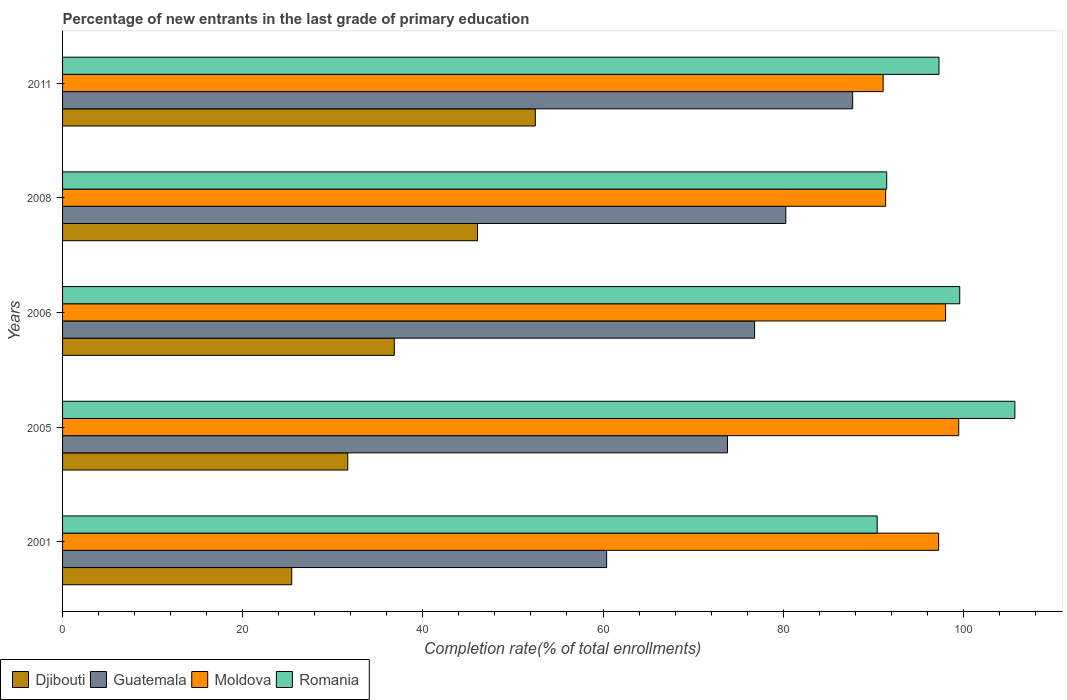How many different coloured bars are there?
Offer a terse response. 4. Are the number of bars on each tick of the Y-axis equal?
Your answer should be very brief. Yes. How many bars are there on the 3rd tick from the top?
Give a very brief answer. 4. How many bars are there on the 2nd tick from the bottom?
Ensure brevity in your answer.  4. What is the percentage of new entrants in Romania in 2006?
Offer a very short reply. 99.6. Across all years, what is the maximum percentage of new entrants in Djibouti?
Your answer should be very brief. 52.48. Across all years, what is the minimum percentage of new entrants in Moldova?
Offer a terse response. 91.1. In which year was the percentage of new entrants in Moldova maximum?
Offer a very short reply. 2005. In which year was the percentage of new entrants in Romania minimum?
Your answer should be very brief. 2001. What is the total percentage of new entrants in Guatemala in the graph?
Provide a short and direct response. 379.07. What is the difference between the percentage of new entrants in Romania in 2005 and that in 2006?
Your answer should be very brief. 6.12. What is the difference between the percentage of new entrants in Moldova in 2006 and the percentage of new entrants in Romania in 2008?
Your response must be concise. 6.54. What is the average percentage of new entrants in Guatemala per year?
Ensure brevity in your answer.  75.81. In the year 2005, what is the difference between the percentage of new entrants in Romania and percentage of new entrants in Moldova?
Provide a short and direct response. 6.23. In how many years, is the percentage of new entrants in Romania greater than 80 %?
Your answer should be compact. 5. What is the ratio of the percentage of new entrants in Guatemala in 2001 to that in 2006?
Provide a short and direct response. 0.79. What is the difference between the highest and the second highest percentage of new entrants in Romania?
Offer a terse response. 6.12. What is the difference between the highest and the lowest percentage of new entrants in Djibouti?
Your response must be concise. 27.04. Is the sum of the percentage of new entrants in Romania in 2006 and 2011 greater than the maximum percentage of new entrants in Guatemala across all years?
Your answer should be very brief. Yes. What does the 1st bar from the top in 2006 represents?
Keep it short and to the point. Romania. What does the 4th bar from the bottom in 2008 represents?
Ensure brevity in your answer.  Romania. How many years are there in the graph?
Offer a very short reply. 5. What is the difference between two consecutive major ticks on the X-axis?
Your answer should be compact. 20. Does the graph contain any zero values?
Your response must be concise. No. Where does the legend appear in the graph?
Provide a succinct answer. Bottom left. How are the legend labels stacked?
Your response must be concise. Horizontal. What is the title of the graph?
Make the answer very short. Percentage of new entrants in the last grade of primary education. Does "Qatar" appear as one of the legend labels in the graph?
Your response must be concise. No. What is the label or title of the X-axis?
Provide a succinct answer. Completion rate(% of total enrollments). What is the Completion rate(% of total enrollments) of Djibouti in 2001?
Provide a succinct answer. 25.44. What is the Completion rate(% of total enrollments) in Guatemala in 2001?
Your answer should be very brief. 60.4. What is the Completion rate(% of total enrollments) in Moldova in 2001?
Your answer should be compact. 97.26. What is the Completion rate(% of total enrollments) in Romania in 2001?
Provide a succinct answer. 90.44. What is the Completion rate(% of total enrollments) of Djibouti in 2005?
Provide a succinct answer. 31.66. What is the Completion rate(% of total enrollments) of Guatemala in 2005?
Your response must be concise. 73.82. What is the Completion rate(% of total enrollments) in Moldova in 2005?
Provide a short and direct response. 99.49. What is the Completion rate(% of total enrollments) of Romania in 2005?
Your answer should be compact. 105.72. What is the Completion rate(% of total enrollments) of Djibouti in 2006?
Offer a very short reply. 36.83. What is the Completion rate(% of total enrollments) in Guatemala in 2006?
Offer a terse response. 76.83. What is the Completion rate(% of total enrollments) in Moldova in 2006?
Your answer should be compact. 98.03. What is the Completion rate(% of total enrollments) in Romania in 2006?
Ensure brevity in your answer.  99.6. What is the Completion rate(% of total enrollments) of Djibouti in 2008?
Your answer should be compact. 46.07. What is the Completion rate(% of total enrollments) of Guatemala in 2008?
Provide a succinct answer. 80.29. What is the Completion rate(% of total enrollments) in Moldova in 2008?
Ensure brevity in your answer.  91.38. What is the Completion rate(% of total enrollments) in Romania in 2008?
Provide a short and direct response. 91.5. What is the Completion rate(% of total enrollments) in Djibouti in 2011?
Give a very brief answer. 52.48. What is the Completion rate(% of total enrollments) in Guatemala in 2011?
Offer a terse response. 87.72. What is the Completion rate(% of total enrollments) of Moldova in 2011?
Offer a very short reply. 91.1. What is the Completion rate(% of total enrollments) in Romania in 2011?
Your answer should be very brief. 97.3. Across all years, what is the maximum Completion rate(% of total enrollments) of Djibouti?
Offer a very short reply. 52.48. Across all years, what is the maximum Completion rate(% of total enrollments) in Guatemala?
Provide a short and direct response. 87.72. Across all years, what is the maximum Completion rate(% of total enrollments) in Moldova?
Give a very brief answer. 99.49. Across all years, what is the maximum Completion rate(% of total enrollments) of Romania?
Offer a very short reply. 105.72. Across all years, what is the minimum Completion rate(% of total enrollments) in Djibouti?
Your answer should be compact. 25.44. Across all years, what is the minimum Completion rate(% of total enrollments) of Guatemala?
Keep it short and to the point. 60.4. Across all years, what is the minimum Completion rate(% of total enrollments) in Moldova?
Provide a short and direct response. 91.1. Across all years, what is the minimum Completion rate(% of total enrollments) in Romania?
Provide a succinct answer. 90.44. What is the total Completion rate(% of total enrollments) in Djibouti in the graph?
Make the answer very short. 192.49. What is the total Completion rate(% of total enrollments) of Guatemala in the graph?
Give a very brief answer. 379.07. What is the total Completion rate(% of total enrollments) of Moldova in the graph?
Give a very brief answer. 477.26. What is the total Completion rate(% of total enrollments) of Romania in the graph?
Ensure brevity in your answer.  484.56. What is the difference between the Completion rate(% of total enrollments) in Djibouti in 2001 and that in 2005?
Offer a very short reply. -6.22. What is the difference between the Completion rate(% of total enrollments) in Guatemala in 2001 and that in 2005?
Your answer should be very brief. -13.42. What is the difference between the Completion rate(% of total enrollments) in Moldova in 2001 and that in 2005?
Make the answer very short. -2.23. What is the difference between the Completion rate(% of total enrollments) of Romania in 2001 and that in 2005?
Your answer should be very brief. -15.28. What is the difference between the Completion rate(% of total enrollments) of Djibouti in 2001 and that in 2006?
Ensure brevity in your answer.  -11.39. What is the difference between the Completion rate(% of total enrollments) in Guatemala in 2001 and that in 2006?
Your response must be concise. -16.43. What is the difference between the Completion rate(% of total enrollments) of Moldova in 2001 and that in 2006?
Make the answer very short. -0.77. What is the difference between the Completion rate(% of total enrollments) in Romania in 2001 and that in 2006?
Offer a very short reply. -9.16. What is the difference between the Completion rate(% of total enrollments) in Djibouti in 2001 and that in 2008?
Keep it short and to the point. -20.63. What is the difference between the Completion rate(% of total enrollments) in Guatemala in 2001 and that in 2008?
Offer a very short reply. -19.89. What is the difference between the Completion rate(% of total enrollments) of Moldova in 2001 and that in 2008?
Your response must be concise. 5.88. What is the difference between the Completion rate(% of total enrollments) in Romania in 2001 and that in 2008?
Your response must be concise. -1.05. What is the difference between the Completion rate(% of total enrollments) of Djibouti in 2001 and that in 2011?
Offer a terse response. -27.04. What is the difference between the Completion rate(% of total enrollments) in Guatemala in 2001 and that in 2011?
Provide a short and direct response. -27.32. What is the difference between the Completion rate(% of total enrollments) of Moldova in 2001 and that in 2011?
Your response must be concise. 6.16. What is the difference between the Completion rate(% of total enrollments) of Romania in 2001 and that in 2011?
Offer a very short reply. -6.86. What is the difference between the Completion rate(% of total enrollments) in Djibouti in 2005 and that in 2006?
Ensure brevity in your answer.  -5.16. What is the difference between the Completion rate(% of total enrollments) of Guatemala in 2005 and that in 2006?
Keep it short and to the point. -3.01. What is the difference between the Completion rate(% of total enrollments) in Moldova in 2005 and that in 2006?
Your response must be concise. 1.46. What is the difference between the Completion rate(% of total enrollments) in Romania in 2005 and that in 2006?
Keep it short and to the point. 6.12. What is the difference between the Completion rate(% of total enrollments) of Djibouti in 2005 and that in 2008?
Provide a succinct answer. -14.41. What is the difference between the Completion rate(% of total enrollments) of Guatemala in 2005 and that in 2008?
Offer a terse response. -6.47. What is the difference between the Completion rate(% of total enrollments) in Moldova in 2005 and that in 2008?
Provide a short and direct response. 8.11. What is the difference between the Completion rate(% of total enrollments) of Romania in 2005 and that in 2008?
Provide a succinct answer. 14.23. What is the difference between the Completion rate(% of total enrollments) in Djibouti in 2005 and that in 2011?
Provide a succinct answer. -20.82. What is the difference between the Completion rate(% of total enrollments) of Guatemala in 2005 and that in 2011?
Give a very brief answer. -13.9. What is the difference between the Completion rate(% of total enrollments) in Moldova in 2005 and that in 2011?
Offer a terse response. 8.39. What is the difference between the Completion rate(% of total enrollments) of Romania in 2005 and that in 2011?
Keep it short and to the point. 8.43. What is the difference between the Completion rate(% of total enrollments) in Djibouti in 2006 and that in 2008?
Provide a short and direct response. -9.24. What is the difference between the Completion rate(% of total enrollments) in Guatemala in 2006 and that in 2008?
Your answer should be compact. -3.46. What is the difference between the Completion rate(% of total enrollments) in Moldova in 2006 and that in 2008?
Provide a short and direct response. 6.65. What is the difference between the Completion rate(% of total enrollments) of Romania in 2006 and that in 2008?
Your answer should be compact. 8.11. What is the difference between the Completion rate(% of total enrollments) in Djibouti in 2006 and that in 2011?
Offer a very short reply. -15.66. What is the difference between the Completion rate(% of total enrollments) in Guatemala in 2006 and that in 2011?
Make the answer very short. -10.89. What is the difference between the Completion rate(% of total enrollments) in Moldova in 2006 and that in 2011?
Offer a very short reply. 6.93. What is the difference between the Completion rate(% of total enrollments) of Romania in 2006 and that in 2011?
Your answer should be very brief. 2.31. What is the difference between the Completion rate(% of total enrollments) of Djibouti in 2008 and that in 2011?
Your answer should be very brief. -6.41. What is the difference between the Completion rate(% of total enrollments) of Guatemala in 2008 and that in 2011?
Your response must be concise. -7.42. What is the difference between the Completion rate(% of total enrollments) in Moldova in 2008 and that in 2011?
Your response must be concise. 0.28. What is the difference between the Completion rate(% of total enrollments) of Romania in 2008 and that in 2011?
Make the answer very short. -5.8. What is the difference between the Completion rate(% of total enrollments) of Djibouti in 2001 and the Completion rate(% of total enrollments) of Guatemala in 2005?
Provide a succinct answer. -48.38. What is the difference between the Completion rate(% of total enrollments) in Djibouti in 2001 and the Completion rate(% of total enrollments) in Moldova in 2005?
Your answer should be compact. -74.05. What is the difference between the Completion rate(% of total enrollments) in Djibouti in 2001 and the Completion rate(% of total enrollments) in Romania in 2005?
Keep it short and to the point. -80.28. What is the difference between the Completion rate(% of total enrollments) in Guatemala in 2001 and the Completion rate(% of total enrollments) in Moldova in 2005?
Offer a very short reply. -39.09. What is the difference between the Completion rate(% of total enrollments) of Guatemala in 2001 and the Completion rate(% of total enrollments) of Romania in 2005?
Your response must be concise. -45.32. What is the difference between the Completion rate(% of total enrollments) of Moldova in 2001 and the Completion rate(% of total enrollments) of Romania in 2005?
Provide a succinct answer. -8.46. What is the difference between the Completion rate(% of total enrollments) of Djibouti in 2001 and the Completion rate(% of total enrollments) of Guatemala in 2006?
Provide a short and direct response. -51.39. What is the difference between the Completion rate(% of total enrollments) in Djibouti in 2001 and the Completion rate(% of total enrollments) in Moldova in 2006?
Make the answer very short. -72.59. What is the difference between the Completion rate(% of total enrollments) of Djibouti in 2001 and the Completion rate(% of total enrollments) of Romania in 2006?
Ensure brevity in your answer.  -74.16. What is the difference between the Completion rate(% of total enrollments) in Guatemala in 2001 and the Completion rate(% of total enrollments) in Moldova in 2006?
Your answer should be compact. -37.63. What is the difference between the Completion rate(% of total enrollments) of Guatemala in 2001 and the Completion rate(% of total enrollments) of Romania in 2006?
Keep it short and to the point. -39.2. What is the difference between the Completion rate(% of total enrollments) in Moldova in 2001 and the Completion rate(% of total enrollments) in Romania in 2006?
Your answer should be compact. -2.34. What is the difference between the Completion rate(% of total enrollments) in Djibouti in 2001 and the Completion rate(% of total enrollments) in Guatemala in 2008?
Ensure brevity in your answer.  -54.85. What is the difference between the Completion rate(% of total enrollments) in Djibouti in 2001 and the Completion rate(% of total enrollments) in Moldova in 2008?
Your response must be concise. -65.94. What is the difference between the Completion rate(% of total enrollments) in Djibouti in 2001 and the Completion rate(% of total enrollments) in Romania in 2008?
Offer a terse response. -66.05. What is the difference between the Completion rate(% of total enrollments) of Guatemala in 2001 and the Completion rate(% of total enrollments) of Moldova in 2008?
Provide a short and direct response. -30.97. What is the difference between the Completion rate(% of total enrollments) of Guatemala in 2001 and the Completion rate(% of total enrollments) of Romania in 2008?
Provide a succinct answer. -31.09. What is the difference between the Completion rate(% of total enrollments) of Moldova in 2001 and the Completion rate(% of total enrollments) of Romania in 2008?
Offer a terse response. 5.77. What is the difference between the Completion rate(% of total enrollments) of Djibouti in 2001 and the Completion rate(% of total enrollments) of Guatemala in 2011?
Your response must be concise. -62.28. What is the difference between the Completion rate(% of total enrollments) in Djibouti in 2001 and the Completion rate(% of total enrollments) in Moldova in 2011?
Provide a succinct answer. -65.66. What is the difference between the Completion rate(% of total enrollments) of Djibouti in 2001 and the Completion rate(% of total enrollments) of Romania in 2011?
Your answer should be very brief. -71.86. What is the difference between the Completion rate(% of total enrollments) of Guatemala in 2001 and the Completion rate(% of total enrollments) of Moldova in 2011?
Your answer should be compact. -30.7. What is the difference between the Completion rate(% of total enrollments) of Guatemala in 2001 and the Completion rate(% of total enrollments) of Romania in 2011?
Keep it short and to the point. -36.89. What is the difference between the Completion rate(% of total enrollments) in Moldova in 2001 and the Completion rate(% of total enrollments) in Romania in 2011?
Give a very brief answer. -0.03. What is the difference between the Completion rate(% of total enrollments) of Djibouti in 2005 and the Completion rate(% of total enrollments) of Guatemala in 2006?
Provide a short and direct response. -45.17. What is the difference between the Completion rate(% of total enrollments) of Djibouti in 2005 and the Completion rate(% of total enrollments) of Moldova in 2006?
Give a very brief answer. -66.37. What is the difference between the Completion rate(% of total enrollments) in Djibouti in 2005 and the Completion rate(% of total enrollments) in Romania in 2006?
Provide a short and direct response. -67.94. What is the difference between the Completion rate(% of total enrollments) of Guatemala in 2005 and the Completion rate(% of total enrollments) of Moldova in 2006?
Provide a succinct answer. -24.21. What is the difference between the Completion rate(% of total enrollments) in Guatemala in 2005 and the Completion rate(% of total enrollments) in Romania in 2006?
Offer a terse response. -25.78. What is the difference between the Completion rate(% of total enrollments) of Moldova in 2005 and the Completion rate(% of total enrollments) of Romania in 2006?
Your answer should be very brief. -0.11. What is the difference between the Completion rate(% of total enrollments) of Djibouti in 2005 and the Completion rate(% of total enrollments) of Guatemala in 2008?
Your answer should be compact. -48.63. What is the difference between the Completion rate(% of total enrollments) of Djibouti in 2005 and the Completion rate(% of total enrollments) of Moldova in 2008?
Your response must be concise. -59.71. What is the difference between the Completion rate(% of total enrollments) in Djibouti in 2005 and the Completion rate(% of total enrollments) in Romania in 2008?
Keep it short and to the point. -59.83. What is the difference between the Completion rate(% of total enrollments) in Guatemala in 2005 and the Completion rate(% of total enrollments) in Moldova in 2008?
Offer a very short reply. -17.56. What is the difference between the Completion rate(% of total enrollments) of Guatemala in 2005 and the Completion rate(% of total enrollments) of Romania in 2008?
Your answer should be compact. -17.67. What is the difference between the Completion rate(% of total enrollments) in Moldova in 2005 and the Completion rate(% of total enrollments) in Romania in 2008?
Offer a terse response. 7.99. What is the difference between the Completion rate(% of total enrollments) in Djibouti in 2005 and the Completion rate(% of total enrollments) in Guatemala in 2011?
Offer a very short reply. -56.05. What is the difference between the Completion rate(% of total enrollments) of Djibouti in 2005 and the Completion rate(% of total enrollments) of Moldova in 2011?
Keep it short and to the point. -59.44. What is the difference between the Completion rate(% of total enrollments) in Djibouti in 2005 and the Completion rate(% of total enrollments) in Romania in 2011?
Ensure brevity in your answer.  -65.63. What is the difference between the Completion rate(% of total enrollments) of Guatemala in 2005 and the Completion rate(% of total enrollments) of Moldova in 2011?
Make the answer very short. -17.28. What is the difference between the Completion rate(% of total enrollments) in Guatemala in 2005 and the Completion rate(% of total enrollments) in Romania in 2011?
Offer a terse response. -23.48. What is the difference between the Completion rate(% of total enrollments) of Moldova in 2005 and the Completion rate(% of total enrollments) of Romania in 2011?
Keep it short and to the point. 2.19. What is the difference between the Completion rate(% of total enrollments) in Djibouti in 2006 and the Completion rate(% of total enrollments) in Guatemala in 2008?
Offer a very short reply. -43.47. What is the difference between the Completion rate(% of total enrollments) in Djibouti in 2006 and the Completion rate(% of total enrollments) in Moldova in 2008?
Give a very brief answer. -54.55. What is the difference between the Completion rate(% of total enrollments) in Djibouti in 2006 and the Completion rate(% of total enrollments) in Romania in 2008?
Provide a short and direct response. -54.67. What is the difference between the Completion rate(% of total enrollments) of Guatemala in 2006 and the Completion rate(% of total enrollments) of Moldova in 2008?
Make the answer very short. -14.55. What is the difference between the Completion rate(% of total enrollments) in Guatemala in 2006 and the Completion rate(% of total enrollments) in Romania in 2008?
Make the answer very short. -14.66. What is the difference between the Completion rate(% of total enrollments) of Moldova in 2006 and the Completion rate(% of total enrollments) of Romania in 2008?
Offer a very short reply. 6.54. What is the difference between the Completion rate(% of total enrollments) of Djibouti in 2006 and the Completion rate(% of total enrollments) of Guatemala in 2011?
Give a very brief answer. -50.89. What is the difference between the Completion rate(% of total enrollments) in Djibouti in 2006 and the Completion rate(% of total enrollments) in Moldova in 2011?
Your answer should be compact. -54.27. What is the difference between the Completion rate(% of total enrollments) of Djibouti in 2006 and the Completion rate(% of total enrollments) of Romania in 2011?
Provide a short and direct response. -60.47. What is the difference between the Completion rate(% of total enrollments) of Guatemala in 2006 and the Completion rate(% of total enrollments) of Moldova in 2011?
Provide a short and direct response. -14.27. What is the difference between the Completion rate(% of total enrollments) in Guatemala in 2006 and the Completion rate(% of total enrollments) in Romania in 2011?
Your answer should be compact. -20.47. What is the difference between the Completion rate(% of total enrollments) in Moldova in 2006 and the Completion rate(% of total enrollments) in Romania in 2011?
Offer a very short reply. 0.73. What is the difference between the Completion rate(% of total enrollments) of Djibouti in 2008 and the Completion rate(% of total enrollments) of Guatemala in 2011?
Offer a very short reply. -41.65. What is the difference between the Completion rate(% of total enrollments) in Djibouti in 2008 and the Completion rate(% of total enrollments) in Moldova in 2011?
Your answer should be very brief. -45.03. What is the difference between the Completion rate(% of total enrollments) of Djibouti in 2008 and the Completion rate(% of total enrollments) of Romania in 2011?
Your answer should be very brief. -51.23. What is the difference between the Completion rate(% of total enrollments) in Guatemala in 2008 and the Completion rate(% of total enrollments) in Moldova in 2011?
Offer a very short reply. -10.81. What is the difference between the Completion rate(% of total enrollments) of Guatemala in 2008 and the Completion rate(% of total enrollments) of Romania in 2011?
Keep it short and to the point. -17. What is the difference between the Completion rate(% of total enrollments) in Moldova in 2008 and the Completion rate(% of total enrollments) in Romania in 2011?
Offer a terse response. -5.92. What is the average Completion rate(% of total enrollments) of Djibouti per year?
Your answer should be compact. 38.5. What is the average Completion rate(% of total enrollments) of Guatemala per year?
Keep it short and to the point. 75.81. What is the average Completion rate(% of total enrollments) in Moldova per year?
Offer a terse response. 95.45. What is the average Completion rate(% of total enrollments) of Romania per year?
Your answer should be compact. 96.91. In the year 2001, what is the difference between the Completion rate(% of total enrollments) in Djibouti and Completion rate(% of total enrollments) in Guatemala?
Make the answer very short. -34.96. In the year 2001, what is the difference between the Completion rate(% of total enrollments) of Djibouti and Completion rate(% of total enrollments) of Moldova?
Your response must be concise. -71.82. In the year 2001, what is the difference between the Completion rate(% of total enrollments) of Djibouti and Completion rate(% of total enrollments) of Romania?
Make the answer very short. -65. In the year 2001, what is the difference between the Completion rate(% of total enrollments) in Guatemala and Completion rate(% of total enrollments) in Moldova?
Your response must be concise. -36.86. In the year 2001, what is the difference between the Completion rate(% of total enrollments) in Guatemala and Completion rate(% of total enrollments) in Romania?
Make the answer very short. -30.04. In the year 2001, what is the difference between the Completion rate(% of total enrollments) in Moldova and Completion rate(% of total enrollments) in Romania?
Ensure brevity in your answer.  6.82. In the year 2005, what is the difference between the Completion rate(% of total enrollments) in Djibouti and Completion rate(% of total enrollments) in Guatemala?
Offer a terse response. -42.16. In the year 2005, what is the difference between the Completion rate(% of total enrollments) in Djibouti and Completion rate(% of total enrollments) in Moldova?
Your answer should be compact. -67.83. In the year 2005, what is the difference between the Completion rate(% of total enrollments) of Djibouti and Completion rate(% of total enrollments) of Romania?
Ensure brevity in your answer.  -74.06. In the year 2005, what is the difference between the Completion rate(% of total enrollments) of Guatemala and Completion rate(% of total enrollments) of Moldova?
Your response must be concise. -25.67. In the year 2005, what is the difference between the Completion rate(% of total enrollments) of Guatemala and Completion rate(% of total enrollments) of Romania?
Give a very brief answer. -31.9. In the year 2005, what is the difference between the Completion rate(% of total enrollments) in Moldova and Completion rate(% of total enrollments) in Romania?
Your answer should be compact. -6.23. In the year 2006, what is the difference between the Completion rate(% of total enrollments) in Djibouti and Completion rate(% of total enrollments) in Guatemala?
Offer a very short reply. -40. In the year 2006, what is the difference between the Completion rate(% of total enrollments) in Djibouti and Completion rate(% of total enrollments) in Moldova?
Your response must be concise. -61.2. In the year 2006, what is the difference between the Completion rate(% of total enrollments) of Djibouti and Completion rate(% of total enrollments) of Romania?
Offer a very short reply. -62.78. In the year 2006, what is the difference between the Completion rate(% of total enrollments) of Guatemala and Completion rate(% of total enrollments) of Moldova?
Provide a succinct answer. -21.2. In the year 2006, what is the difference between the Completion rate(% of total enrollments) in Guatemala and Completion rate(% of total enrollments) in Romania?
Make the answer very short. -22.77. In the year 2006, what is the difference between the Completion rate(% of total enrollments) of Moldova and Completion rate(% of total enrollments) of Romania?
Provide a short and direct response. -1.57. In the year 2008, what is the difference between the Completion rate(% of total enrollments) in Djibouti and Completion rate(% of total enrollments) in Guatemala?
Keep it short and to the point. -34.22. In the year 2008, what is the difference between the Completion rate(% of total enrollments) of Djibouti and Completion rate(% of total enrollments) of Moldova?
Provide a short and direct response. -45.31. In the year 2008, what is the difference between the Completion rate(% of total enrollments) of Djibouti and Completion rate(% of total enrollments) of Romania?
Your response must be concise. -45.42. In the year 2008, what is the difference between the Completion rate(% of total enrollments) of Guatemala and Completion rate(% of total enrollments) of Moldova?
Provide a short and direct response. -11.08. In the year 2008, what is the difference between the Completion rate(% of total enrollments) in Guatemala and Completion rate(% of total enrollments) in Romania?
Your answer should be compact. -11.2. In the year 2008, what is the difference between the Completion rate(% of total enrollments) of Moldova and Completion rate(% of total enrollments) of Romania?
Offer a very short reply. -0.12. In the year 2011, what is the difference between the Completion rate(% of total enrollments) of Djibouti and Completion rate(% of total enrollments) of Guatemala?
Your answer should be compact. -35.24. In the year 2011, what is the difference between the Completion rate(% of total enrollments) in Djibouti and Completion rate(% of total enrollments) in Moldova?
Provide a succinct answer. -38.62. In the year 2011, what is the difference between the Completion rate(% of total enrollments) of Djibouti and Completion rate(% of total enrollments) of Romania?
Your response must be concise. -44.81. In the year 2011, what is the difference between the Completion rate(% of total enrollments) of Guatemala and Completion rate(% of total enrollments) of Moldova?
Your response must be concise. -3.38. In the year 2011, what is the difference between the Completion rate(% of total enrollments) of Guatemala and Completion rate(% of total enrollments) of Romania?
Your answer should be compact. -9.58. In the year 2011, what is the difference between the Completion rate(% of total enrollments) in Moldova and Completion rate(% of total enrollments) in Romania?
Ensure brevity in your answer.  -6.2. What is the ratio of the Completion rate(% of total enrollments) of Djibouti in 2001 to that in 2005?
Your answer should be very brief. 0.8. What is the ratio of the Completion rate(% of total enrollments) in Guatemala in 2001 to that in 2005?
Offer a terse response. 0.82. What is the ratio of the Completion rate(% of total enrollments) in Moldova in 2001 to that in 2005?
Offer a terse response. 0.98. What is the ratio of the Completion rate(% of total enrollments) of Romania in 2001 to that in 2005?
Ensure brevity in your answer.  0.86. What is the ratio of the Completion rate(% of total enrollments) of Djibouti in 2001 to that in 2006?
Provide a succinct answer. 0.69. What is the ratio of the Completion rate(% of total enrollments) of Guatemala in 2001 to that in 2006?
Your answer should be compact. 0.79. What is the ratio of the Completion rate(% of total enrollments) in Moldova in 2001 to that in 2006?
Your answer should be very brief. 0.99. What is the ratio of the Completion rate(% of total enrollments) of Romania in 2001 to that in 2006?
Your answer should be compact. 0.91. What is the ratio of the Completion rate(% of total enrollments) in Djibouti in 2001 to that in 2008?
Give a very brief answer. 0.55. What is the ratio of the Completion rate(% of total enrollments) of Guatemala in 2001 to that in 2008?
Make the answer very short. 0.75. What is the ratio of the Completion rate(% of total enrollments) of Moldova in 2001 to that in 2008?
Your answer should be very brief. 1.06. What is the ratio of the Completion rate(% of total enrollments) in Djibouti in 2001 to that in 2011?
Your answer should be very brief. 0.48. What is the ratio of the Completion rate(% of total enrollments) of Guatemala in 2001 to that in 2011?
Provide a short and direct response. 0.69. What is the ratio of the Completion rate(% of total enrollments) of Moldova in 2001 to that in 2011?
Offer a terse response. 1.07. What is the ratio of the Completion rate(% of total enrollments) of Romania in 2001 to that in 2011?
Make the answer very short. 0.93. What is the ratio of the Completion rate(% of total enrollments) in Djibouti in 2005 to that in 2006?
Make the answer very short. 0.86. What is the ratio of the Completion rate(% of total enrollments) of Guatemala in 2005 to that in 2006?
Make the answer very short. 0.96. What is the ratio of the Completion rate(% of total enrollments) in Moldova in 2005 to that in 2006?
Offer a terse response. 1.01. What is the ratio of the Completion rate(% of total enrollments) of Romania in 2005 to that in 2006?
Offer a terse response. 1.06. What is the ratio of the Completion rate(% of total enrollments) in Djibouti in 2005 to that in 2008?
Provide a succinct answer. 0.69. What is the ratio of the Completion rate(% of total enrollments) of Guatemala in 2005 to that in 2008?
Provide a succinct answer. 0.92. What is the ratio of the Completion rate(% of total enrollments) in Moldova in 2005 to that in 2008?
Your answer should be very brief. 1.09. What is the ratio of the Completion rate(% of total enrollments) in Romania in 2005 to that in 2008?
Keep it short and to the point. 1.16. What is the ratio of the Completion rate(% of total enrollments) of Djibouti in 2005 to that in 2011?
Ensure brevity in your answer.  0.6. What is the ratio of the Completion rate(% of total enrollments) of Guatemala in 2005 to that in 2011?
Your answer should be very brief. 0.84. What is the ratio of the Completion rate(% of total enrollments) in Moldova in 2005 to that in 2011?
Your answer should be compact. 1.09. What is the ratio of the Completion rate(% of total enrollments) of Romania in 2005 to that in 2011?
Offer a terse response. 1.09. What is the ratio of the Completion rate(% of total enrollments) of Djibouti in 2006 to that in 2008?
Your response must be concise. 0.8. What is the ratio of the Completion rate(% of total enrollments) of Guatemala in 2006 to that in 2008?
Offer a terse response. 0.96. What is the ratio of the Completion rate(% of total enrollments) of Moldova in 2006 to that in 2008?
Offer a terse response. 1.07. What is the ratio of the Completion rate(% of total enrollments) in Romania in 2006 to that in 2008?
Make the answer very short. 1.09. What is the ratio of the Completion rate(% of total enrollments) of Djibouti in 2006 to that in 2011?
Your answer should be very brief. 0.7. What is the ratio of the Completion rate(% of total enrollments) in Guatemala in 2006 to that in 2011?
Offer a very short reply. 0.88. What is the ratio of the Completion rate(% of total enrollments) in Moldova in 2006 to that in 2011?
Provide a succinct answer. 1.08. What is the ratio of the Completion rate(% of total enrollments) in Romania in 2006 to that in 2011?
Give a very brief answer. 1.02. What is the ratio of the Completion rate(% of total enrollments) of Djibouti in 2008 to that in 2011?
Provide a short and direct response. 0.88. What is the ratio of the Completion rate(% of total enrollments) of Guatemala in 2008 to that in 2011?
Give a very brief answer. 0.92. What is the ratio of the Completion rate(% of total enrollments) in Moldova in 2008 to that in 2011?
Offer a very short reply. 1. What is the ratio of the Completion rate(% of total enrollments) in Romania in 2008 to that in 2011?
Your response must be concise. 0.94. What is the difference between the highest and the second highest Completion rate(% of total enrollments) in Djibouti?
Your response must be concise. 6.41. What is the difference between the highest and the second highest Completion rate(% of total enrollments) of Guatemala?
Offer a terse response. 7.42. What is the difference between the highest and the second highest Completion rate(% of total enrollments) of Moldova?
Offer a terse response. 1.46. What is the difference between the highest and the second highest Completion rate(% of total enrollments) of Romania?
Provide a short and direct response. 6.12. What is the difference between the highest and the lowest Completion rate(% of total enrollments) of Djibouti?
Make the answer very short. 27.04. What is the difference between the highest and the lowest Completion rate(% of total enrollments) of Guatemala?
Ensure brevity in your answer.  27.32. What is the difference between the highest and the lowest Completion rate(% of total enrollments) of Moldova?
Provide a short and direct response. 8.39. What is the difference between the highest and the lowest Completion rate(% of total enrollments) in Romania?
Your answer should be very brief. 15.28. 